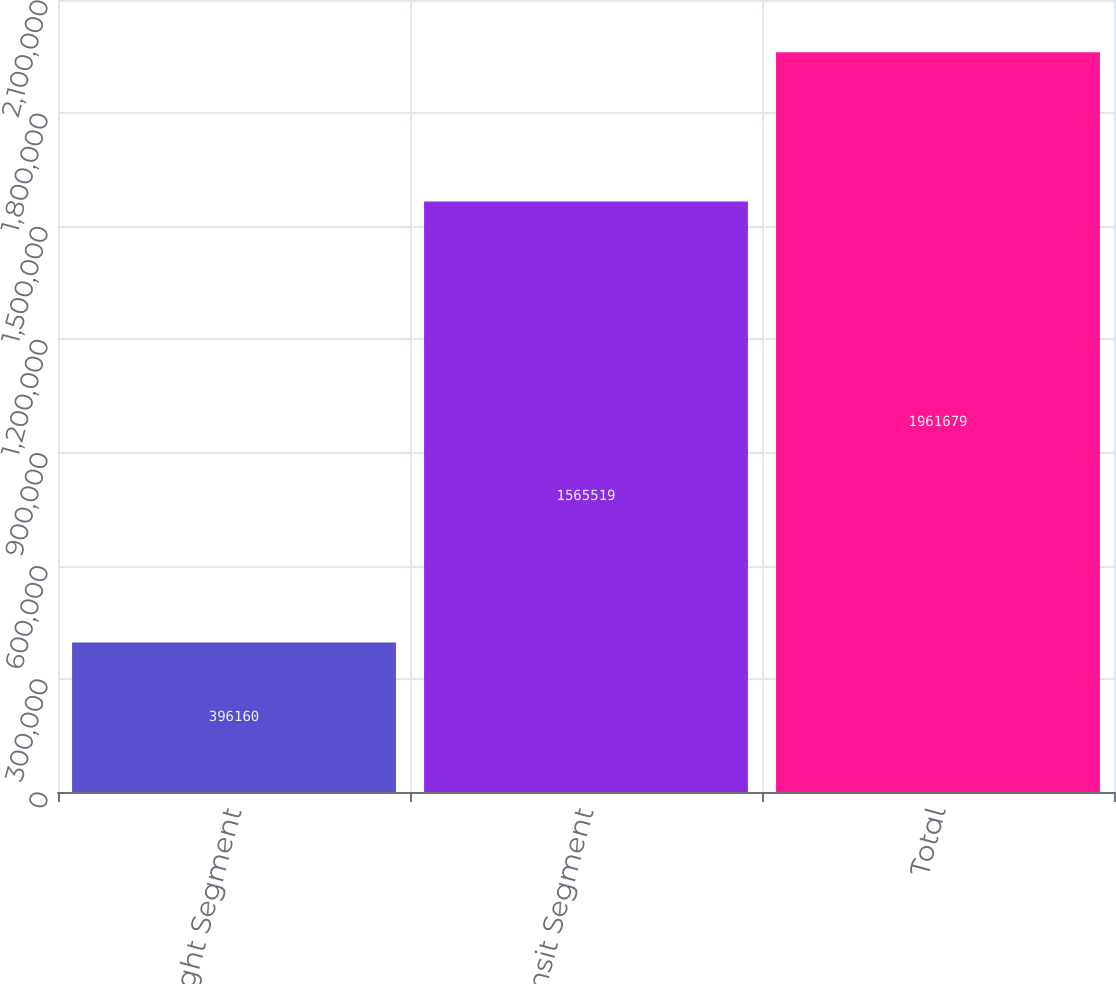Convert chart to OTSL. <chart><loc_0><loc_0><loc_500><loc_500><bar_chart><fcel>Freight Segment<fcel>Transit Segment<fcel>Total<nl><fcel>396160<fcel>1.56552e+06<fcel>1.96168e+06<nl></chart> 